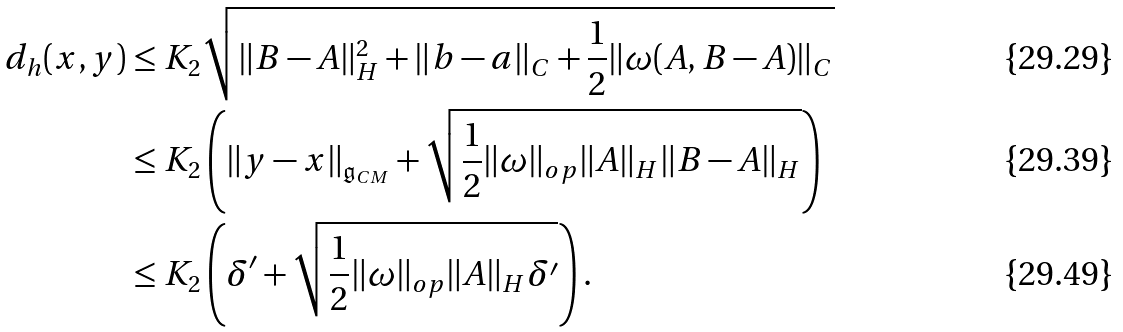Convert formula to latex. <formula><loc_0><loc_0><loc_500><loc_500>d _ { h } ( x , y ) & \leq K _ { 2 } \sqrt { \| B - A \| _ { H } ^ { 2 } + \| b - a \| _ { C } + \frac { 1 } { 2 } \| \omega ( A , B - A ) \| _ { C } } \\ & \leq K _ { 2 } \left ( \| y - x \| _ { \mathfrak { g } _ { C M } } + \sqrt { \frac { 1 } { 2 } \| \omega \| _ { o p } \| A \| _ { H } \| B - A \| _ { H } } \right ) \\ & \leq K _ { 2 } \left ( \delta ^ { \prime } + \sqrt { \frac { 1 } { 2 } \| \omega \| _ { o p } \| A \| _ { H } \delta ^ { \prime } } \right ) .</formula> 